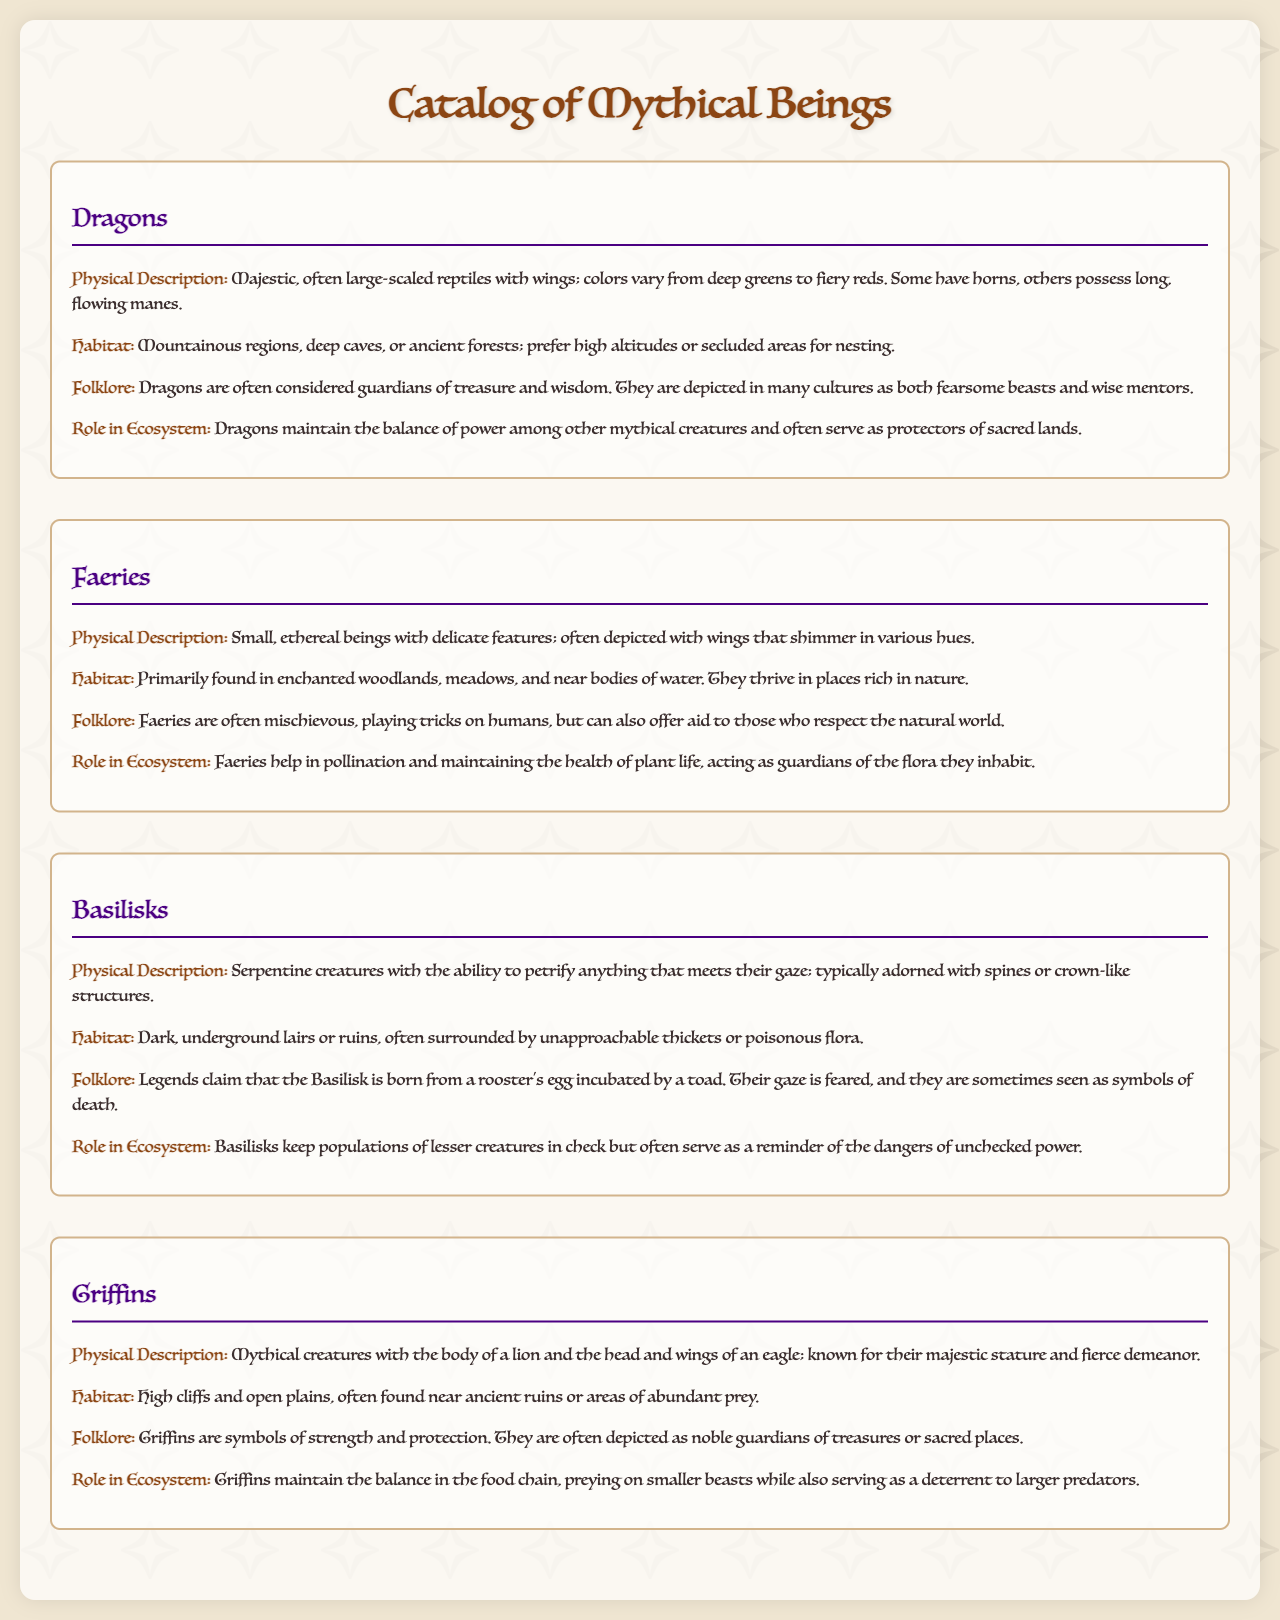What is the physical description of Dragons? Dragons are described as majestic, often large-scaled reptiles with wings; colors vary from deep greens to fiery reds.
Answer: Majestic, often large-scaled reptiles with wings; colors vary from deep greens to fiery reds Where do Faeries primarily inhabit? The document states that Faeries are primarily found in enchanted woodlands, meadows, and near bodies of water.
Answer: Enchanted woodlands, meadows, and near bodies of water What mythical creature can petrify anything that meets its gaze? The document indicates that Basilisks have the ability to petrify anything that meets their gaze.
Answer: Basilisks Which creature is known for its majestic stature and fierce demeanor? The description of Griffins highlights their majestic stature and fierce demeanor.
Answer: Griffins How do Faeries contribute to the ecosystem? According to the document, Faeries help in pollination and maintaining the health of plant life, acting as guardians of the flora they inhabit.
Answer: Pollination and maintaining the health of plant life What symbolism is associated with Griffins? The document mentions that Griffins are symbols of strength and protection.
Answer: Strength and protection What role do Dragons play in the ecosystem? The text emphasizes that Dragons maintain the balance of power among other mythical creatures and often serve as protectors of sacred lands.
Answer: Maintain the balance of power and protectors of sacred lands What is a unique characteristic of Basilisks? The document states that Basilisks are sometimes seen as symbols of death, which is a unique characteristic mentioned.
Answer: Symbols of death What habitat do Griffins prefer? The document states that Griffins are found in high cliffs and open plains, often near ancient ruins.
Answer: High cliffs and open plains 